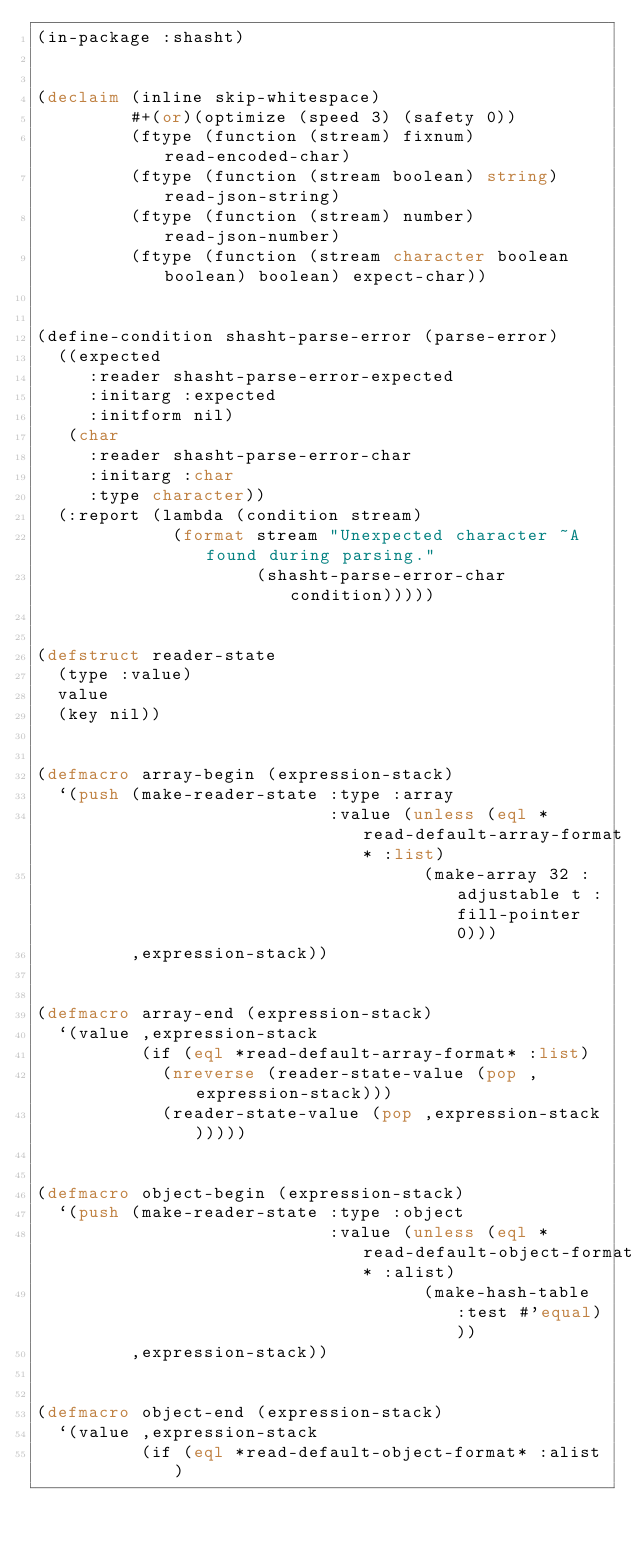Convert code to text. <code><loc_0><loc_0><loc_500><loc_500><_Lisp_>(in-package :shasht)


(declaim (inline skip-whitespace)
         #+(or)(optimize (speed 3) (safety 0))
         (ftype (function (stream) fixnum) read-encoded-char)
         (ftype (function (stream boolean) string) read-json-string)
         (ftype (function (stream) number) read-json-number)
         (ftype (function (stream character boolean boolean) boolean) expect-char))


(define-condition shasht-parse-error (parse-error)
  ((expected
     :reader shasht-parse-error-expected
     :initarg :expected
     :initform nil)
   (char
     :reader shasht-parse-error-char
     :initarg :char
     :type character))
  (:report (lambda (condition stream)
             (format stream "Unexpected character ~A found during parsing."
                     (shasht-parse-error-char condition)))))


(defstruct reader-state
  (type :value)
  value
  (key nil))


(defmacro array-begin (expression-stack)
  `(push (make-reader-state :type :array
                            :value (unless (eql *read-default-array-format* :list)
                                     (make-array 32 :adjustable t :fill-pointer 0)))
         ,expression-stack))


(defmacro array-end (expression-stack)
  `(value ,expression-stack
          (if (eql *read-default-array-format* :list)
            (nreverse (reader-state-value (pop ,expression-stack)))
            (reader-state-value (pop ,expression-stack)))))


(defmacro object-begin (expression-stack)
  `(push (make-reader-state :type :object
                            :value (unless (eql *read-default-object-format* :alist)
                                     (make-hash-table :test #'equal)))
         ,expression-stack))


(defmacro object-end (expression-stack)
  `(value ,expression-stack
          (if (eql *read-default-object-format* :alist)</code> 